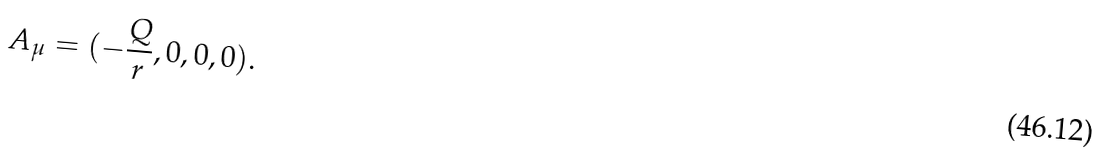<formula> <loc_0><loc_0><loc_500><loc_500>A _ { \mu } = ( - \frac { Q } { r } , 0 , 0 , 0 ) .</formula> 